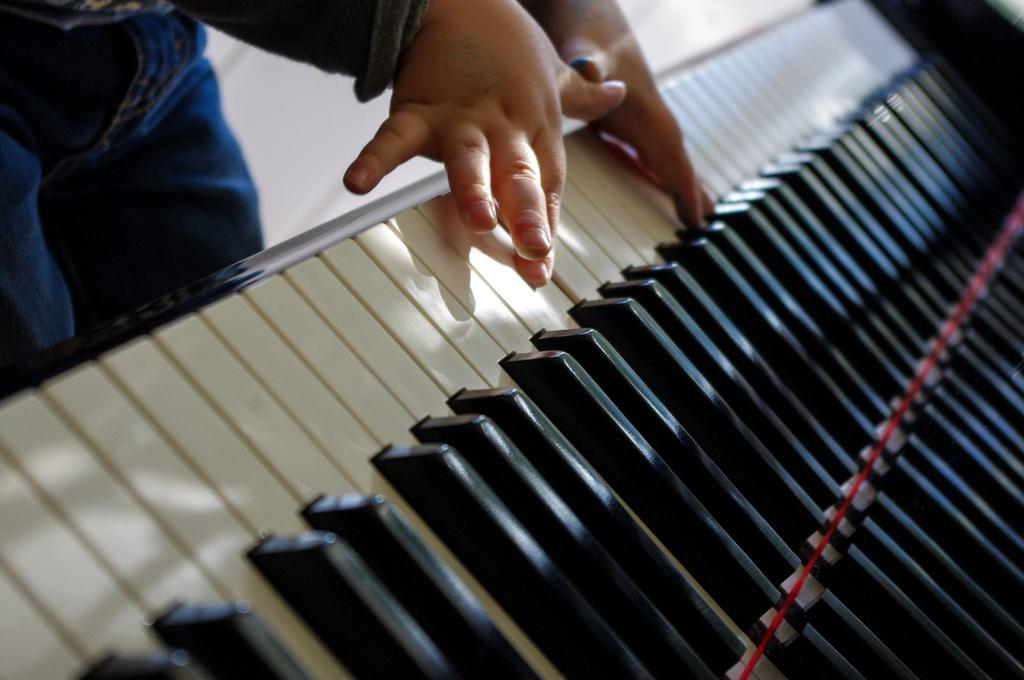What can be seen in the image? There are two little hands in the image. What are the hands doing? The hands are pressing keys on a piano board. What type of beast can be seen roaming around the piano in the image? There is no beast present in the image; it only features two little hands pressing keys on a piano board. 